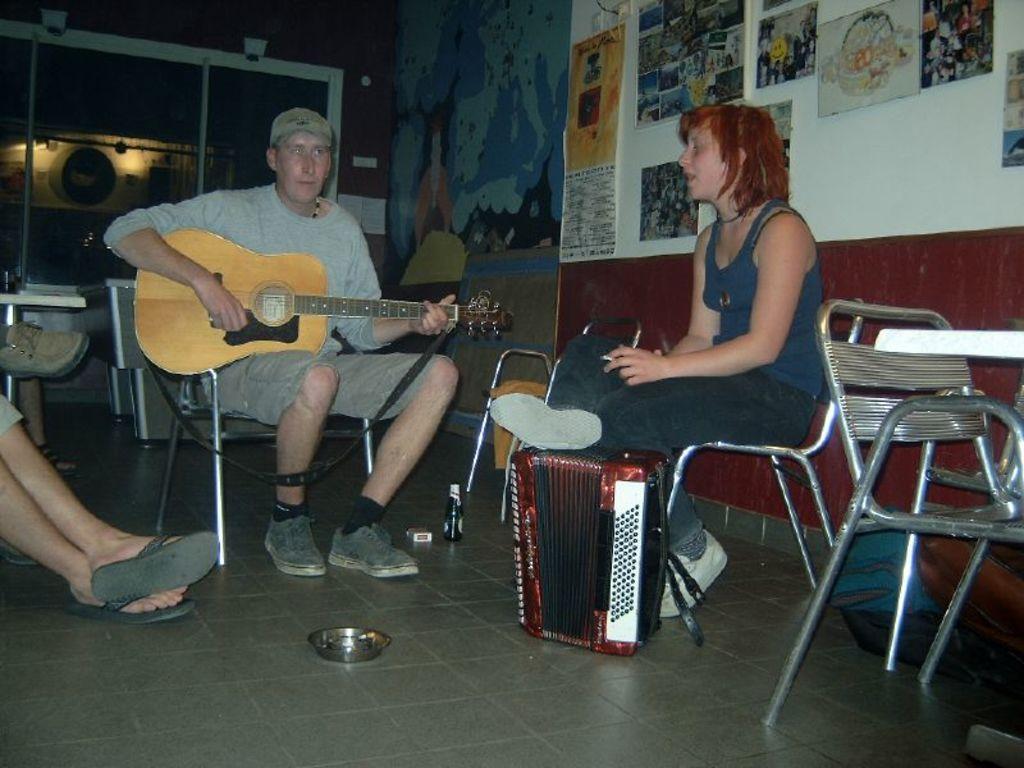In one or two sentences, can you explain what this image depicts? In the image we can see three persons were sitting on the chair. And the center person he is holding guitar. In the background there is a wall,notice board,light and chair. 